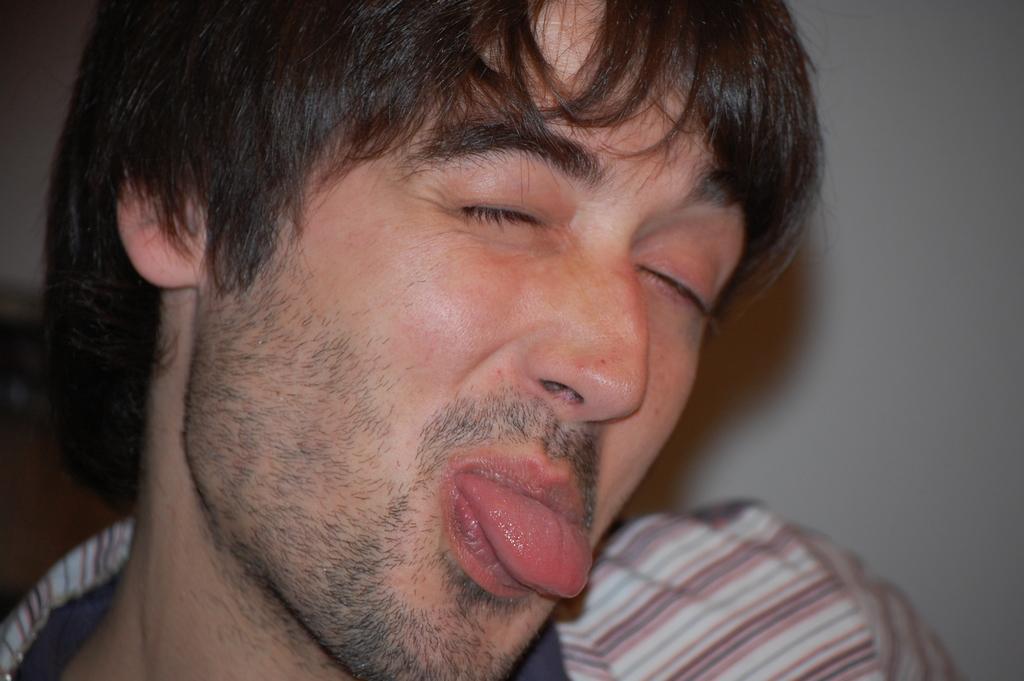Could you give a brief overview of what you see in this image? There is a man with closed eyes and keeping the tongue outside the mouth. In the background there is a wall. 